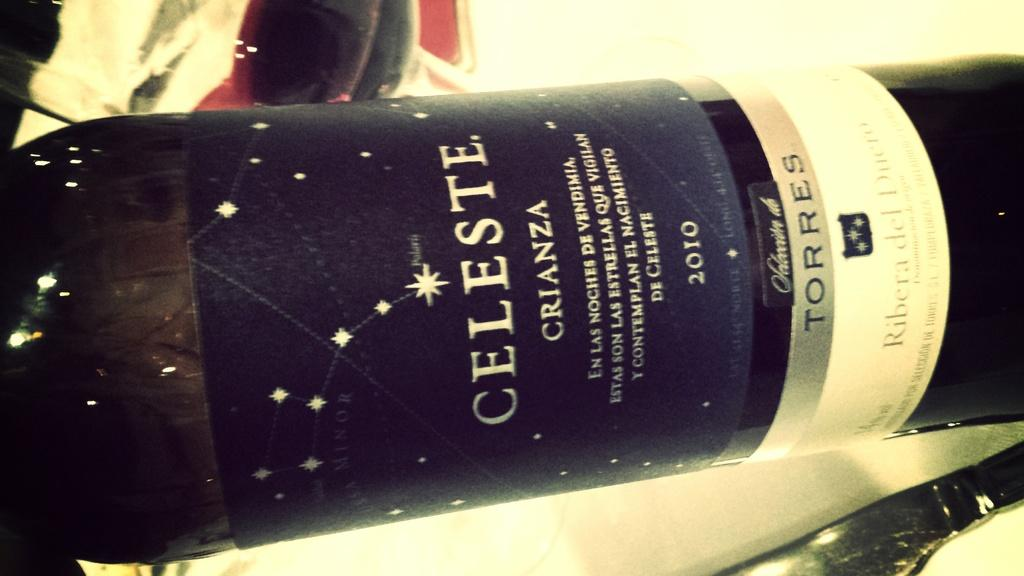<image>
Offer a succinct explanation of the picture presented. A bottle says Celeste Crianza 2010 on it. 